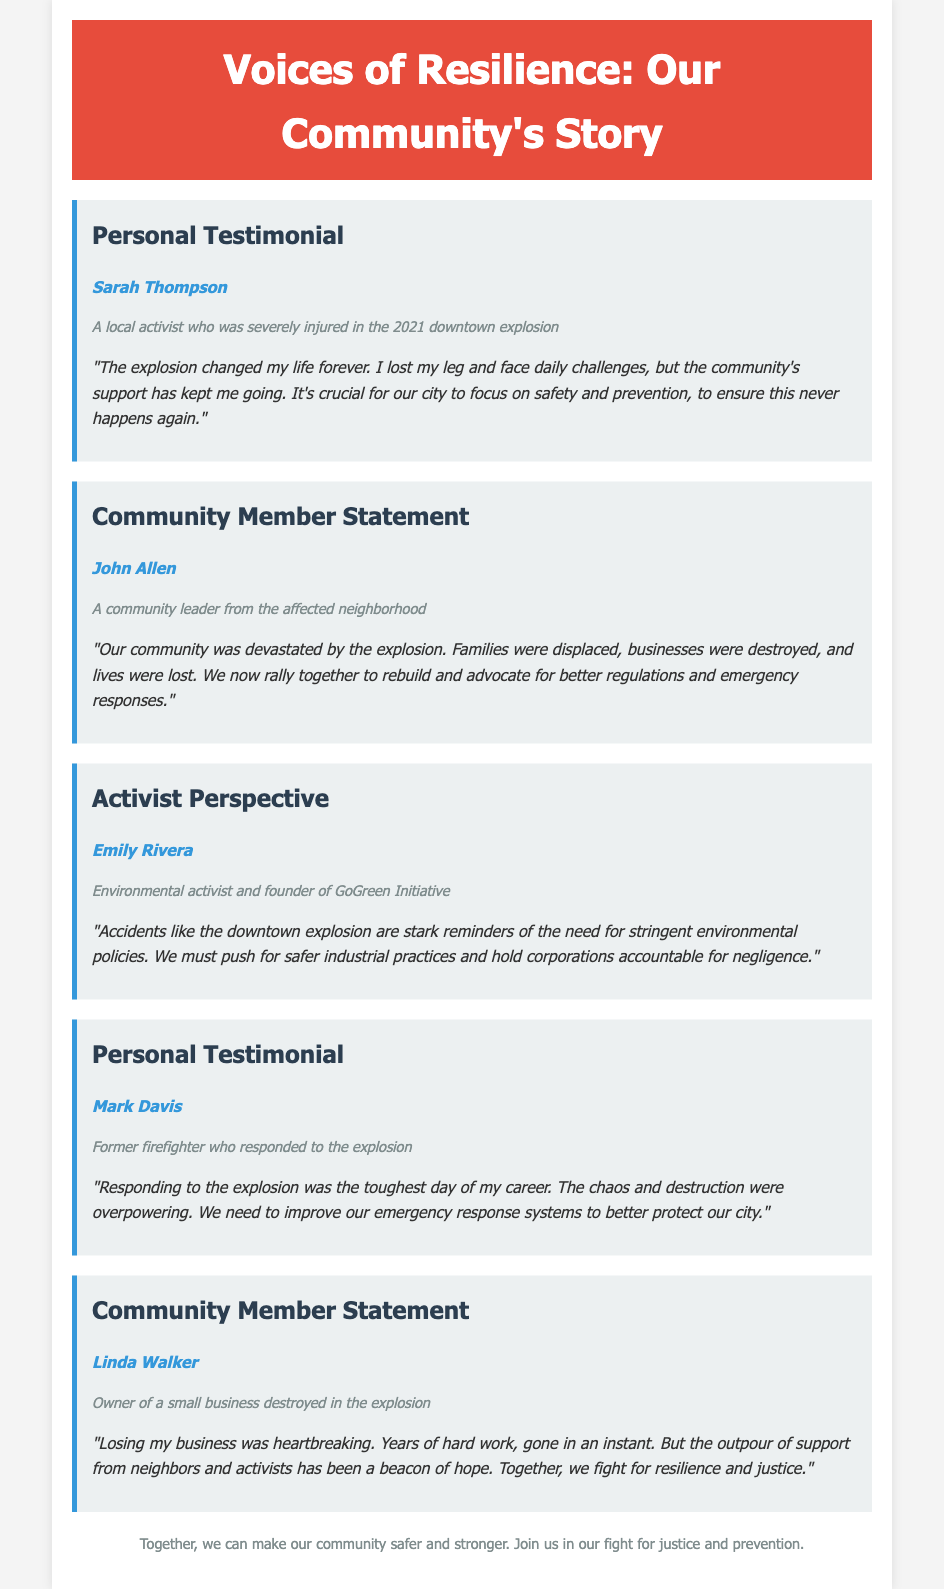What is the title of the document? The title of the document is indicated in the header section.
Answer: Voices of Resilience: Our Community's Story Who is the speaker of the first personal testimonial? The first personal testimonial lists the speaker's name directly beneath the heading.
Answer: Sarah Thompson What is the main theme of Emily Rivera's perspective? Emily Rivera's statement emphasizes the need for safer industrial practices due to the explosion.
Answer: Environmental policies How many testimonials are featured in the document? The document contains a total count of testimonials presented.
Answer: Five What significant event affected the community mentioned in the document? The specific incident that impacted the community is mentioned in the testimonials.
Answer: Downtown explosion Who owned a small business destroyed in the explosion? The document assigns a specific individual to the destroyed business description.
Answer: Linda Walker 